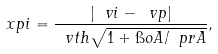Convert formula to latex. <formula><loc_0><loc_0><loc_500><loc_500>\ x p i = \frac { | \ v i - \ v p | } { \ v t h \sqrt { 1 + \i o { A } / \ p r { A } } } ,</formula> 